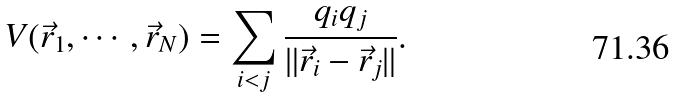<formula> <loc_0><loc_0><loc_500><loc_500>V ( \vec { r } _ { 1 } , \cdots , \vec { r } _ { N } ) = \sum _ { i < j } \frac { q _ { i } q _ { j } } { \| \vec { r } _ { i } - \vec { r } _ { j } \| } .</formula> 